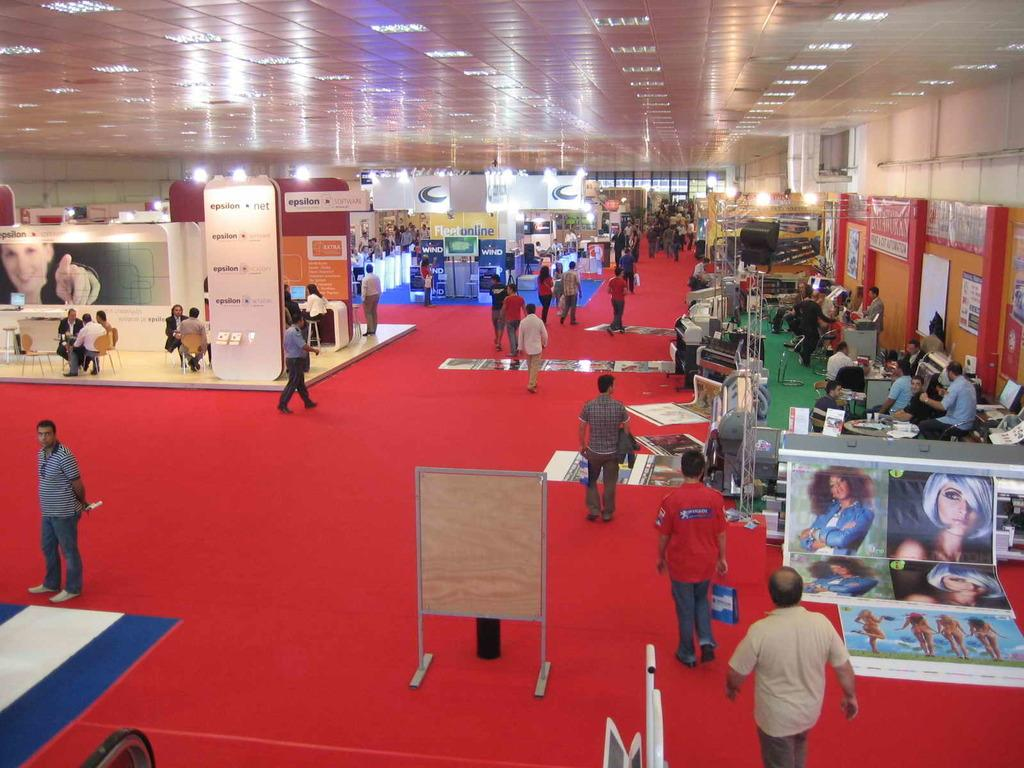What type of setting is depicted in the image? The image shows many stalls, which suggests it is a market or bazaar. How many people can be seen in the image? There are many people in the image. What is at the bottom of the image? There is a carpet at the bottom of the image. What is at the top of the image? There is a roof at the top of the image. Can you see a friend of yours in the image? There is no information about your friends in the image, so it cannot be determined if they are present. Is there a giraffe in the image? There is no giraffe present in the image. 